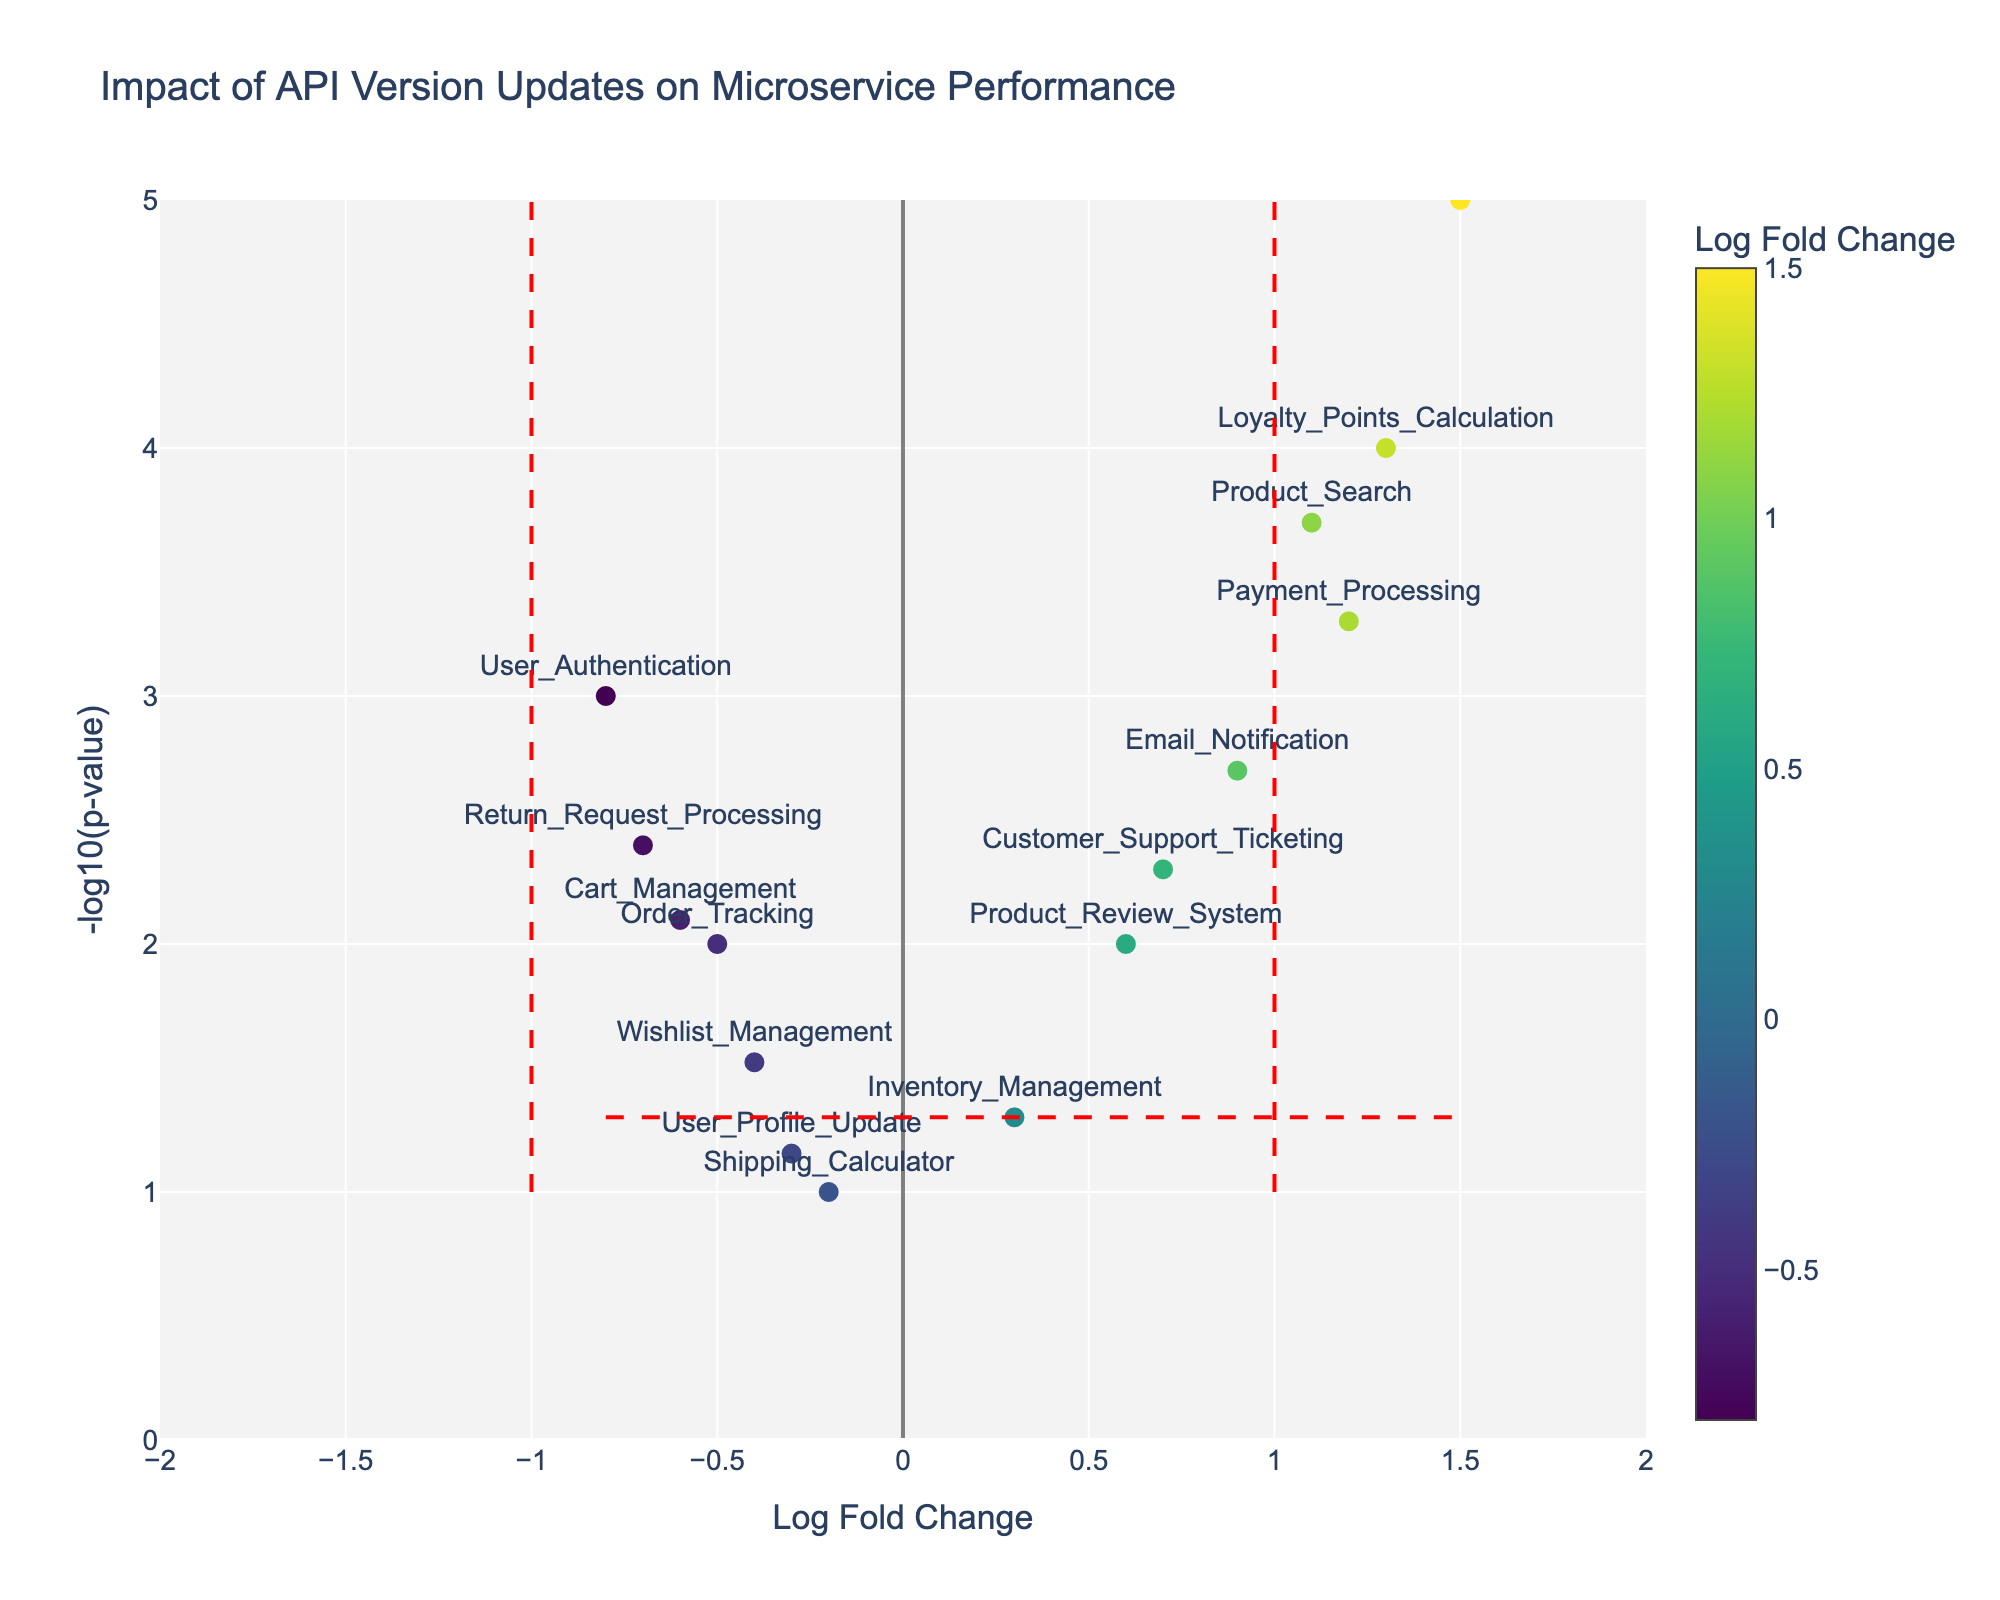How many unique data points are plotted on the graph? Look at the number of different API endpoints labeled in the figure. Each endpoint represents a unique data point. There are 15 unique API endpoints listed in the data.
Answer: 15 Which API endpoint shows the highest log fold change? Check the data points and identify which endpoint has the maximum value of log fold change. The "Product_Recommendation" endpoint has the highest log fold change of 1.5.
Answer: Product_Recommendation What is the y-value corresponding to the "Payment_Processing" API endpoint? The y-value is determined by the -log10 of the p-value of the "Payment_Processing" endpoint. For "Payment_Processing," the p-value is 0.0005, so -log10(0.0005) = 3.3.
Answer: 3.3 Which API endpoints are considered statistically significant, and how do you know? An API endpoint is considered statistically significant if its p-value is less than 0.05, meaning its y-value (-log10(p)) is greater than 1.3 (since -log10(0.05) = 1.3). The endpoints with y-values above 1.3 are: "User_Authentication," "Payment_Processing," "Product_Recommendation," "Customer_Support_Ticketing," "Product_Search," "Cart_Management," "Email_Notification," "Loyalty_Points_Calculation," and "Return_Request_Processing."
Answer: 9 endpoints Which API endpoints have a negative log fold change? Look at the endpoints that have a log fold change less than zero. The endpoints are "User_Authentication," "Order_Tracking," "Shipping_Calculator," "Wishlist_Management," "Cart_Management," "User_Profile_Update," and "Return_Request_Processing."
Answer: 7 endpoints What is the vertical threshold line (y-value) for determining statistical significance? The horizontal threshold line corresponds to a p-value of 0.05. The y-value is calculated as -log10(0.05) = 1.3.
Answer: 1.3 Among the statistically significant API endpoints, which one shows the lowest fold change and what is its value? From the endpoints above the y-value threshold of 1.3, the one with the lowest log fold change is "Return_Request_Processing" with a log fold change of -0.7.
Answer: Return_Request_Processing with -0.7 Which endpoint has the highest -log10(p-value) and what is its log fold change? Identify the point with the highest y-value on the plot and note its log fold change. The "Product_Recommendation" endpoint has the highest -log10(p-value) of 5 and a log fold change of 1.5.
Answer: Product_Recommendation with 1.5 